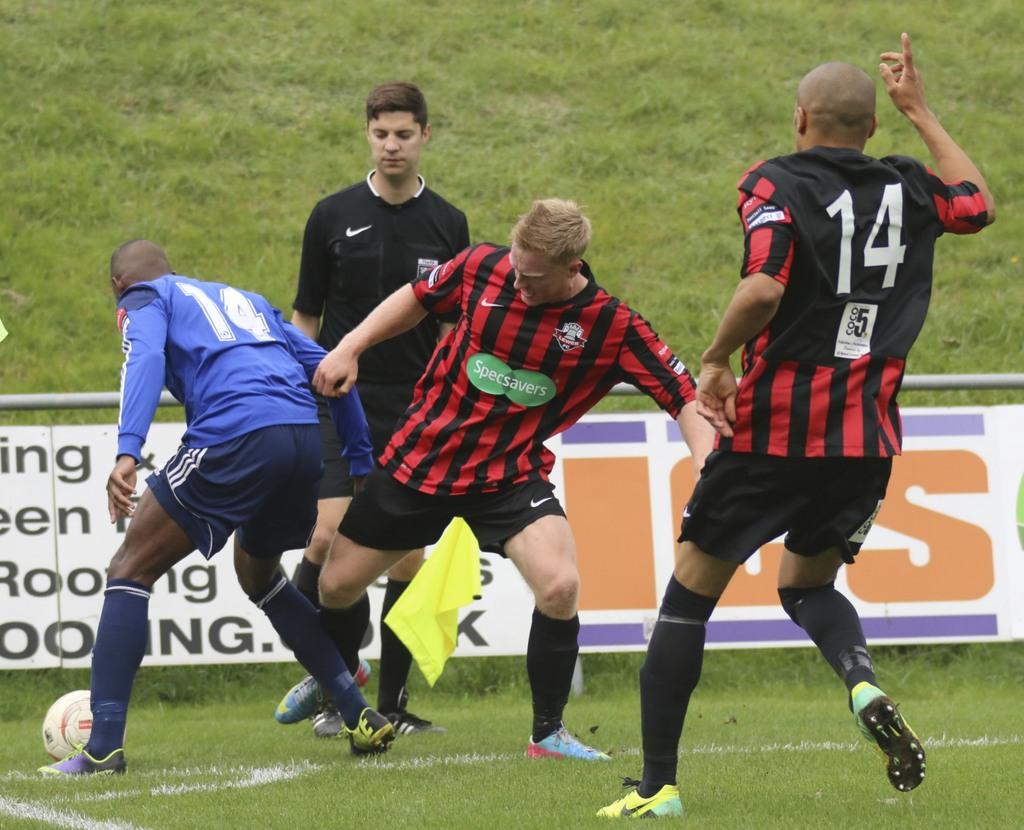What number is the player on the very right?
Make the answer very short. 14. What team does the blonde man in red play for?
Provide a succinct answer. Specsavers. 